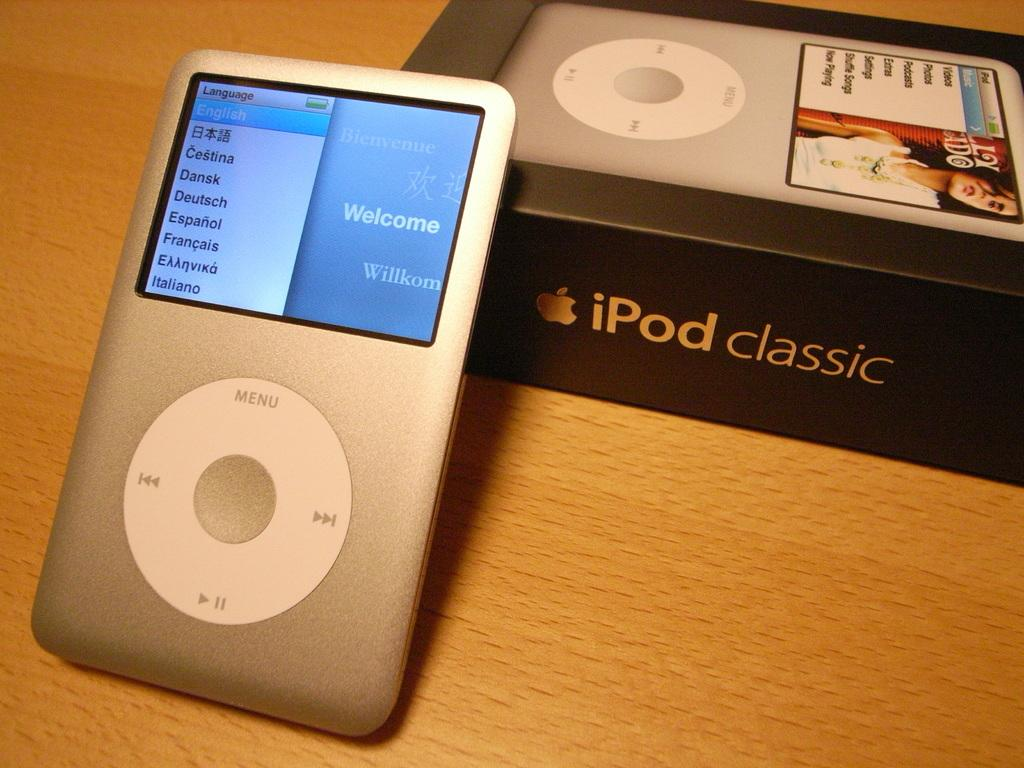What type of furniture is present in the image? There is a table in the image. What object is placed on the table? There is an iPod box on the table. What is on top of the iPod box? There is an iPod on top of the iPod box. What advice does the owl give to the iPod in the image? There is no owl present in the image, so it cannot provide any advice to the iPod. 